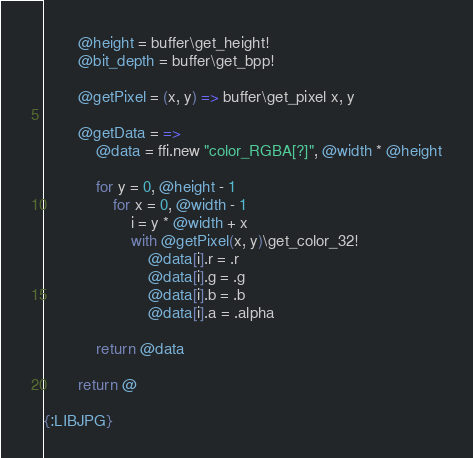<code> <loc_0><loc_0><loc_500><loc_500><_MoonScript_>        @height = buffer\get_height!
        @bit_depth = buffer\get_bpp!

        @getPixel = (x, y) => buffer\get_pixel x, y

        @getData = =>
            @data = ffi.new "color_RGBA[?]", @width * @height

            for y = 0, @height - 1
                for x = 0, @width - 1
                    i = y * @width + x
                    with @getPixel(x, y)\get_color_32!
                        @data[i].r = .r
                        @data[i].g = .g
                        @data[i].b = .b
                        @data[i].a = .alpha

            return @data

        return @

{:LIBJPG}</code> 